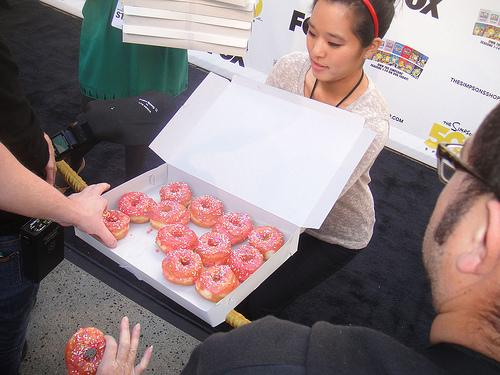Briefly explain what kind of event is taking place in the image. This is a Simpsons event where people are gathered and enjoying pink frosted donuts. Give a description of the donuts in the image. The donuts are pink frosted with white sprinkles and are placed in an open box. What material is the floor made of in the image? The floor is made of marble. Describe the appearance of the woman in the image. The woman is Asian with a red headband in her hair, she is wearing a white shirt and has a black cord around her neck. What is the action happening between the man and the donut? The man is grabbing a donut with his hand. What are the distinctive features of the man present in the image? The man has thick sideburns, dark hair, and is wearing glasses on his head. Describe the hair accessory of the woman in the image.  The woman is wearing a red headband in her hair. How many pink frosted doughnuts are visible in the image? There are 6 pink frosted doughnuts visible in the image. What is the woman in the picture holding? The woman is holding a pink frosted doughnut with white sprinkles. Mention any text or numbers present in the image. There are yellow numbers on the wall and "The Simpsons Shop" written on a banner. 